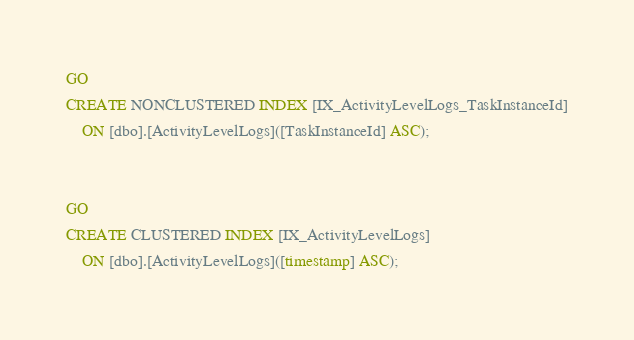Convert code to text. <code><loc_0><loc_0><loc_500><loc_500><_SQL_>

GO
CREATE NONCLUSTERED INDEX [IX_ActivityLevelLogs_TaskInstanceId]
    ON [dbo].[ActivityLevelLogs]([TaskInstanceId] ASC);


GO
CREATE CLUSTERED INDEX [IX_ActivityLevelLogs]
    ON [dbo].[ActivityLevelLogs]([timestamp] ASC);

</code> 